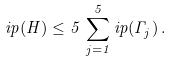Convert formula to latex. <formula><loc_0><loc_0><loc_500><loc_500>\L i p ( H ) \leq 5 \, \sum _ { j = 1 } ^ { 5 } \L i p ( \Gamma _ { j } ) \, .</formula> 